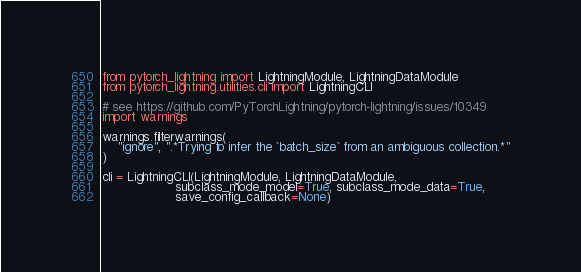<code> <loc_0><loc_0><loc_500><loc_500><_Python_>from pytorch_lightning import LightningModule, LightningDataModule
from pytorch_lightning.utilities.cli import LightningCLI

# see https://github.com/PyTorchLightning/pytorch-lightning/issues/10349
import warnings

warnings.filterwarnings(
    "ignore", ".*Trying to infer the `batch_size` from an ambiguous collection.*"
)

cli = LightningCLI(LightningModule, LightningDataModule, 
                   subclass_mode_model=True, subclass_mode_data=True,
                   save_config_callback=None)</code> 